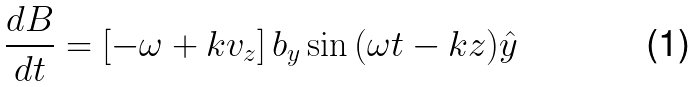Convert formula to latex. <formula><loc_0><loc_0><loc_500><loc_500>\frac { d B } { d t } = \left [ { - \omega + k v _ { z } } \right ] b _ { y } \sin { ( \omega t - k z ) } \hat { y }</formula> 